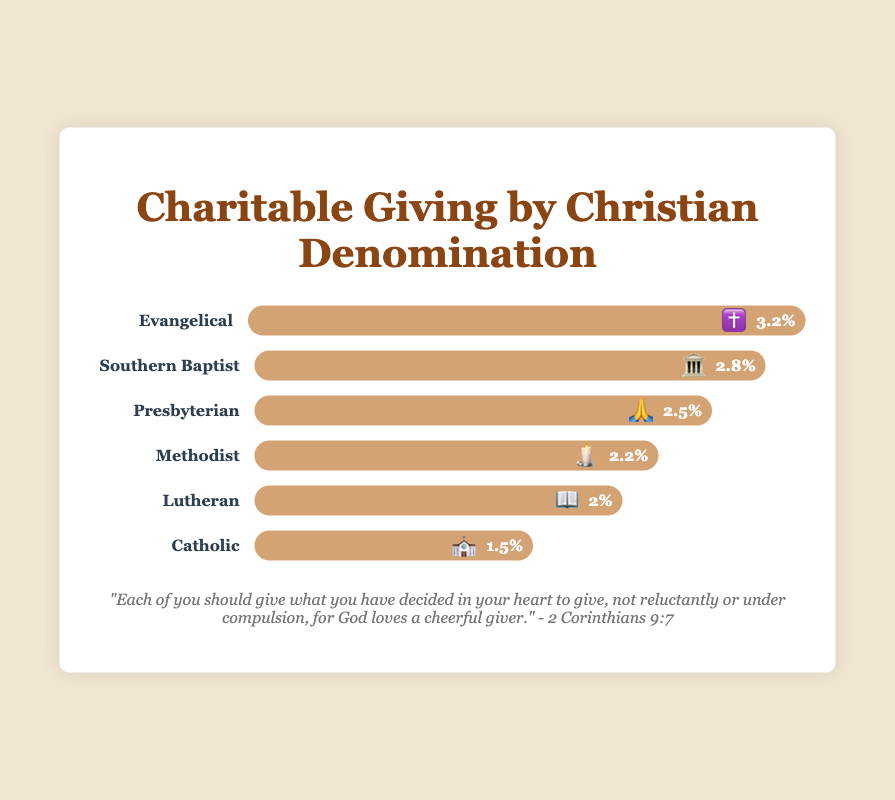Who gives the highest percentage of their income to charity? Look for the denomination with the largest bar. Evangelical gives 3.2%, which is the highest percentage among all denominations shown.
Answer: Evangelical ✝️ Which denomination has the smallest charitable giving percentage? Identify the bar with the smallest value. The Catholic denomination has the smallest percentage of 1.5%.
Answer: Catholic ⛪ What's the total percentage of charitable giving for Methodist and Lutheran combined? Add the giving percentages of the Methodist and Lutheran denominations: Methodist = 2.2%, Lutheran = 2.0%. Thus, 2.2% + 2.0% = 4.2%.
Answer: 4.2% Compare the giving percentages of Southern Baptist and Presbyterian. Which is higher? Check the bar lengths for Southern Baptist (2.8%) and Presbyterian (2.5%). Southern Baptist's percentage is higher.
Answer: Southern Baptist 🏛️ How much less is the Catholic giving percentage compared to the Evangelical percentage? Subtract the Catholic percentage from the Evangelical percentage: Evangelical = 3.2%, Catholic = 1.5%. Difference = 3.2% - 1.5% = 1.7%.
Answer: 1.7% What is the average charitable giving percentage among all the denominations? Sum the percentages of all denominations and divide by the number of denominations: (2.8 + 1.5 + 2.2 + 2.0 + 2.5 + 3.2) / 6 = 2.37%.
Answer: 2.37% How many denominations give more than 2% of their income to charity? Count the number of denominations with percentages greater than 2%: Southern Baptist, Methodist, Presbyterian, Evangelical.
Answer: 4 Rank the denominations by their charitable giving percentages from highest to lowest. Order the denominations based on the values of their giving percentages: Evangelical (3.2%), Southern Baptist (2.8%), Presbyterian (2.5%), Methodist (2.2%), Lutheran (2.0%), Catholic (1.5%).
Answer: Evangelical > Southern Baptist > Presbyterian > Methodist > Lutheran > Catholic What percentage do Southern Baptist and Evangelical combined give in charity? Add the giving percentages of Southern Baptist and Evangelical: Southern Baptist = 2.8%, Evangelical = 3.2%. Combined = 2.8% + 3.2% = 6.0%.
Answer: 6.0% Which denominations have a giving percentage between 2% and 3%? Identify denominations with percentages within the specified range: Southern Baptist (2.8%), Methodist (2.2%), Lutheran (2.0%), Presbyterian (2.5%).
Answer: Southern Baptist 🏛️, Methodist 🕯️, Lutheran 📖, Presbyterian 🙏 